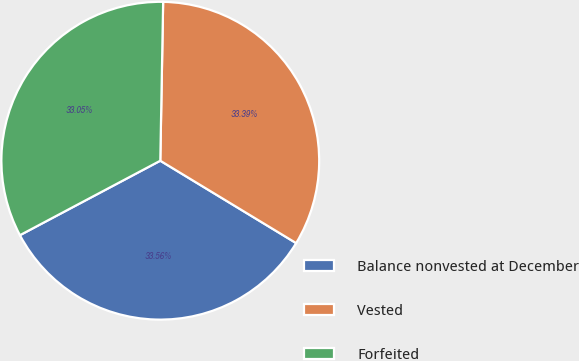<chart> <loc_0><loc_0><loc_500><loc_500><pie_chart><fcel>Balance nonvested at December<fcel>Vested<fcel>Forfeited<nl><fcel>33.56%<fcel>33.39%<fcel>33.05%<nl></chart> 